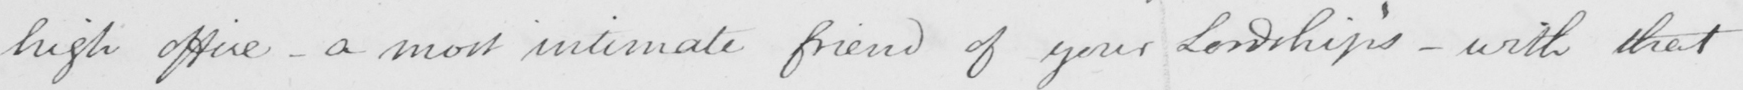Please provide the text content of this handwritten line. high office  _  a most intimate friend of your Lordship ' s  _  with that 